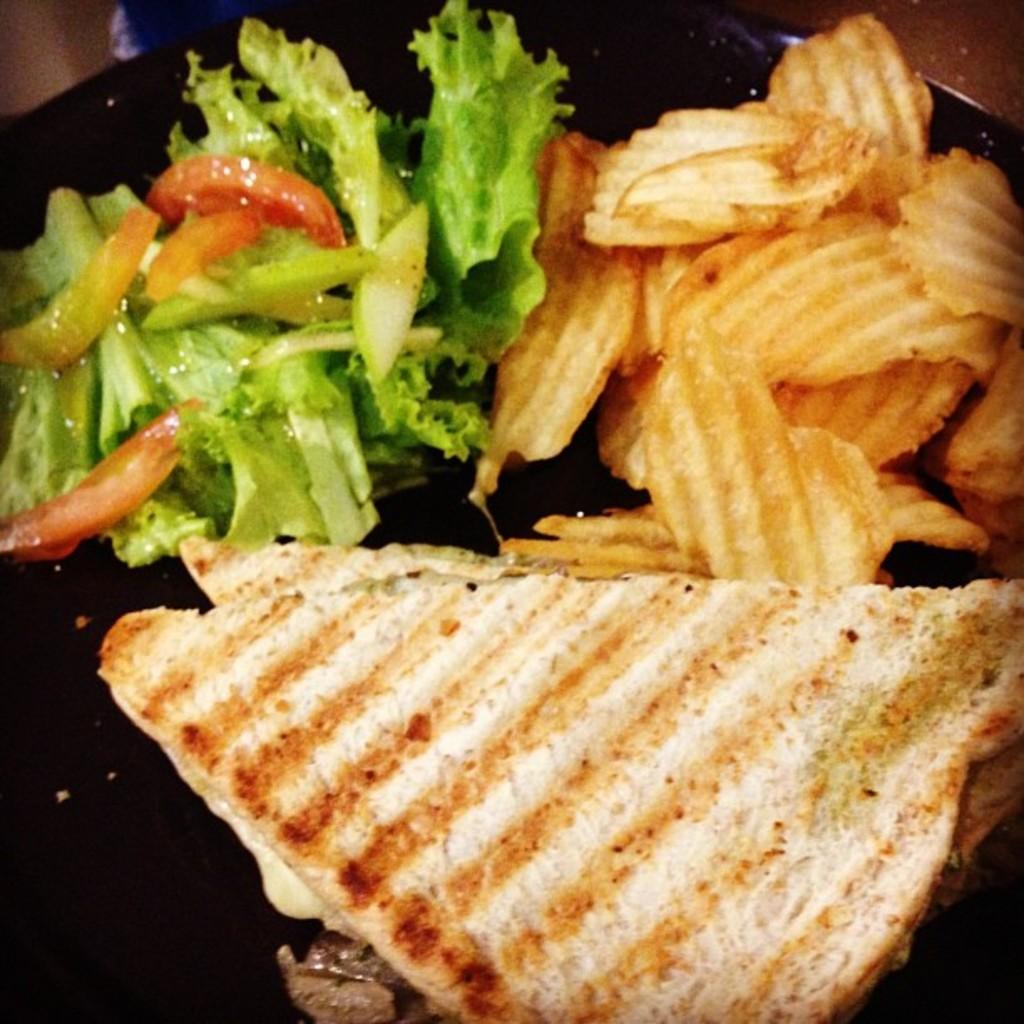What is present in the image related to food? There is food in the image. How is the food arranged or contained? The food is in a plate. Where is the plate with food located? The plate is placed on a surface. Can you describe the seashore visible in the image? There is no seashore present in the image; it features food in a plate placed on a surface. What type of selection is available for the food in the image? The image does not show a selection of food; it only shows food in a plate. 